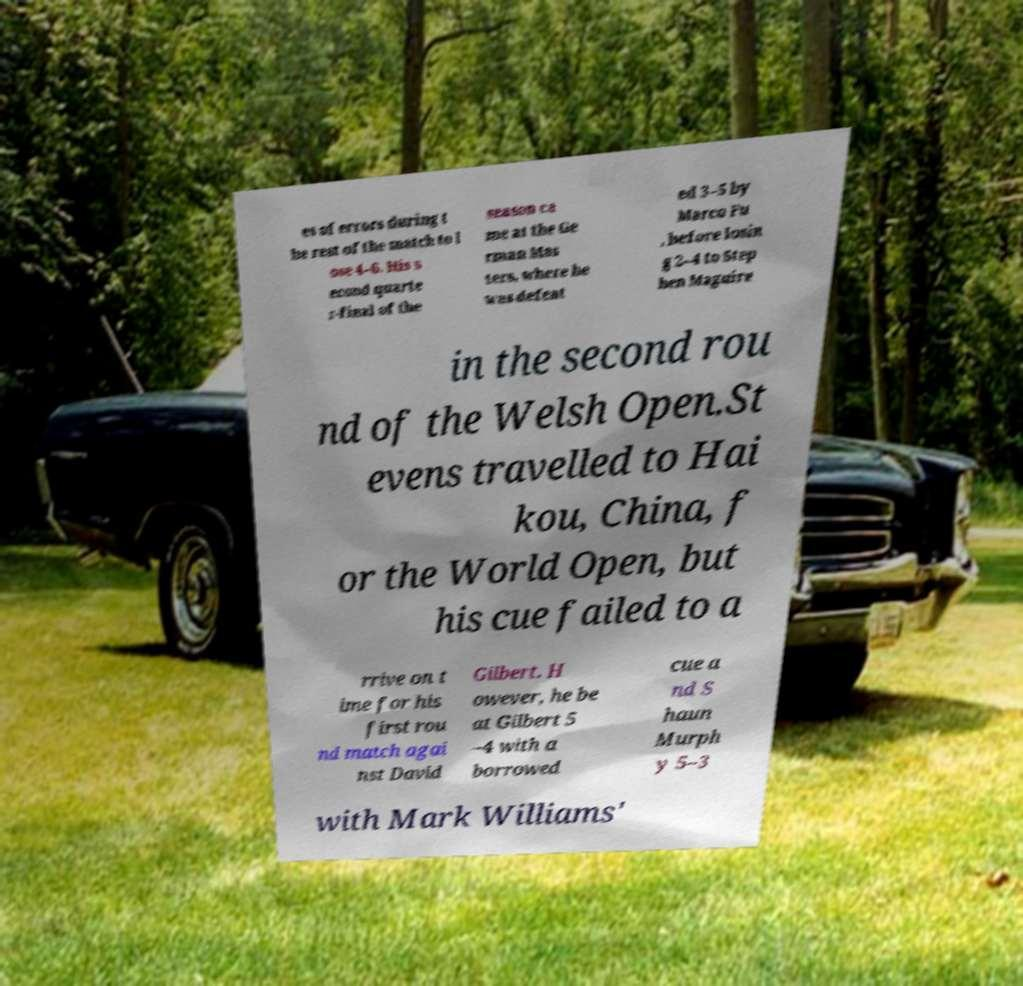Can you read and provide the text displayed in the image?This photo seems to have some interesting text. Can you extract and type it out for me? es of errors during t he rest of the match to l ose 4–6. His s econd quarte r-final of the season ca me at the Ge rman Mas ters, where he was defeat ed 3–5 by Marco Fu , before losin g 2–4 to Step hen Maguire in the second rou nd of the Welsh Open.St evens travelled to Hai kou, China, f or the World Open, but his cue failed to a rrive on t ime for his first rou nd match agai nst David Gilbert. H owever, he be at Gilbert 5 –4 with a borrowed cue a nd S haun Murph y 5–3 with Mark Williams' 